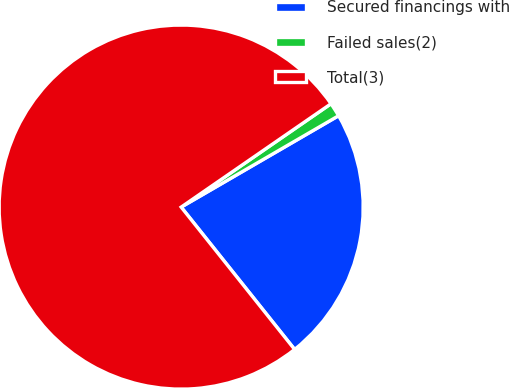<chart> <loc_0><loc_0><loc_500><loc_500><pie_chart><fcel>Secured financings with<fcel>Failed sales(2)<fcel>Total(3)<nl><fcel>22.66%<fcel>1.24%<fcel>76.1%<nl></chart> 